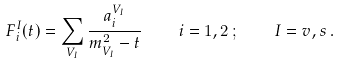Convert formula to latex. <formula><loc_0><loc_0><loc_500><loc_500>F _ { i } ^ { I } ( t ) = \sum _ { V _ { I } } \frac { a _ { i } ^ { V _ { I } } } { m ^ { 2 } _ { V _ { I } } - t } \, \quad i = 1 , 2 \, ; \, \quad I = v , s \, .</formula> 